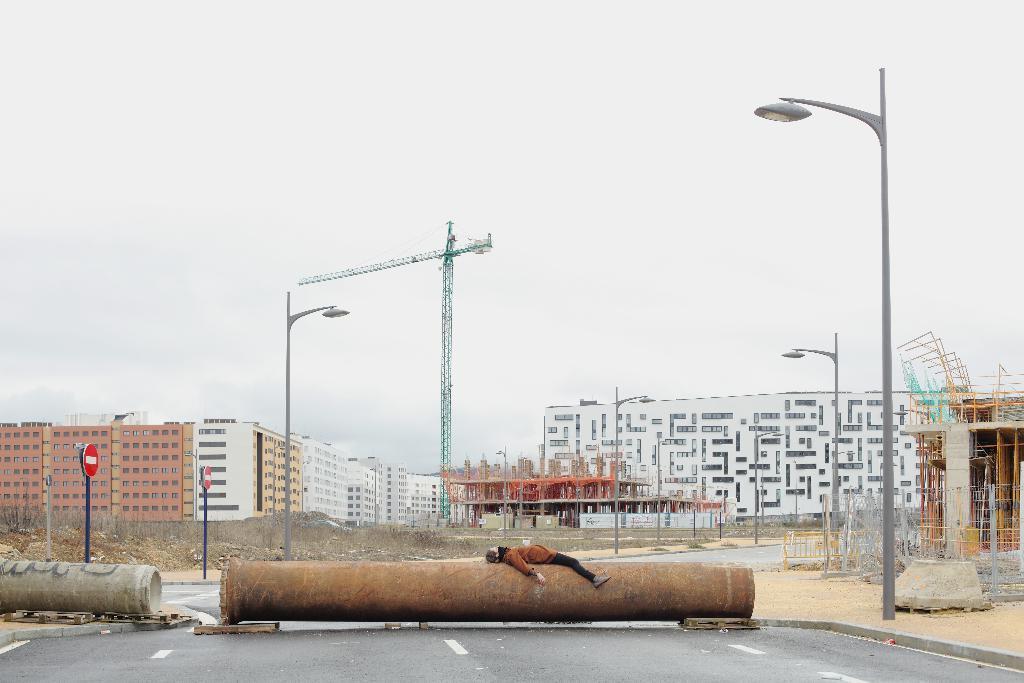Describe this image in one or two sentences. In this picture there is a pole in the center of the image and there is a person, who is lying on it and there are buildings in the background area of the image. 